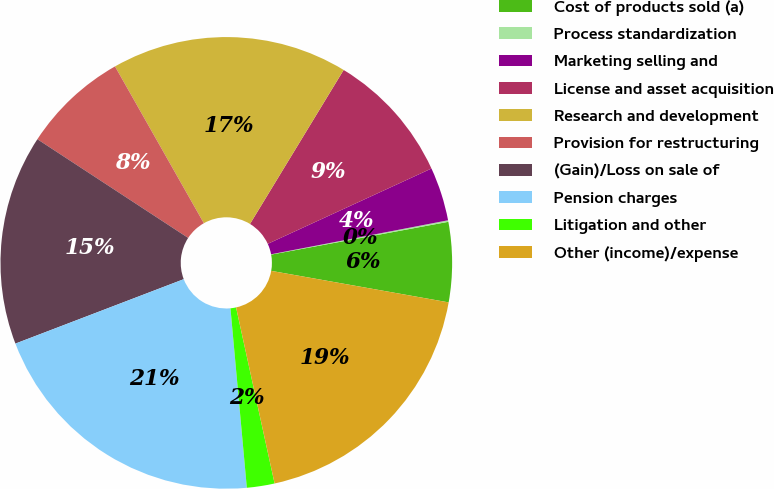Convert chart. <chart><loc_0><loc_0><loc_500><loc_500><pie_chart><fcel>Cost of products sold (a)<fcel>Process standardization<fcel>Marketing selling and<fcel>License and asset acquisition<fcel>Research and development<fcel>Provision for restructuring<fcel>(Gain)/Loss on sale of<fcel>Pension charges<fcel>Litigation and other<fcel>Other (income)/expense<nl><fcel>5.71%<fcel>0.11%<fcel>3.84%<fcel>9.44%<fcel>16.9%<fcel>7.57%<fcel>15.04%<fcel>20.63%<fcel>1.98%<fcel>18.77%<nl></chart> 